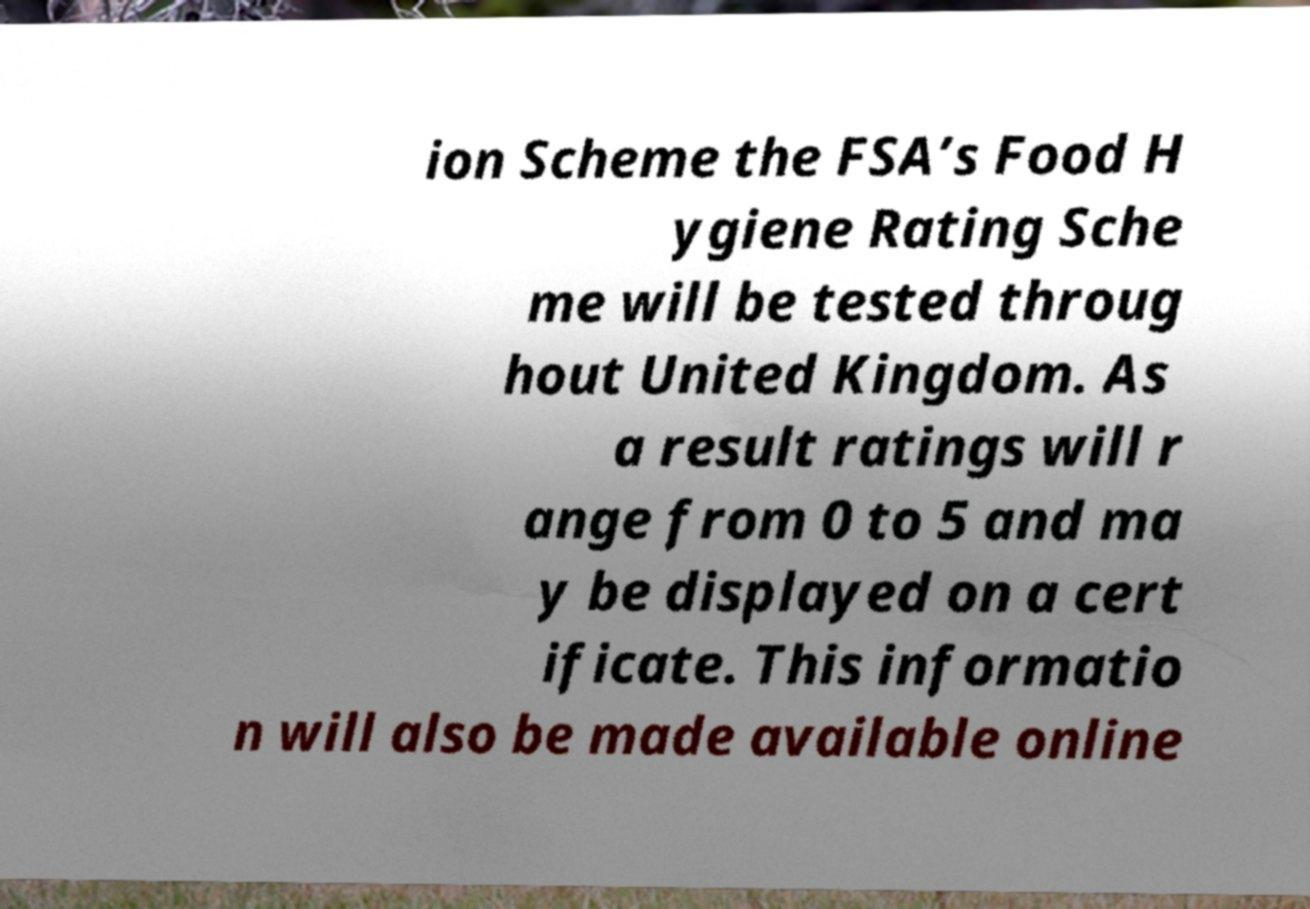What messages or text are displayed in this image? I need them in a readable, typed format. ion Scheme the FSA’s Food H ygiene Rating Sche me will be tested throug hout United Kingdom. As a result ratings will r ange from 0 to 5 and ma y be displayed on a cert ificate. This informatio n will also be made available online 